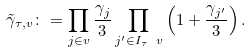<formula> <loc_0><loc_0><loc_500><loc_500>\tilde { \gamma } _ { \tau , v } \colon = \prod _ { j \in v } \frac { \gamma _ { j } } { 3 } \prod _ { j ^ { \prime } \in I _ { \tau } \ v } \left ( 1 + \frac { \gamma _ { j ^ { \prime } } } { 3 } \right ) .</formula> 